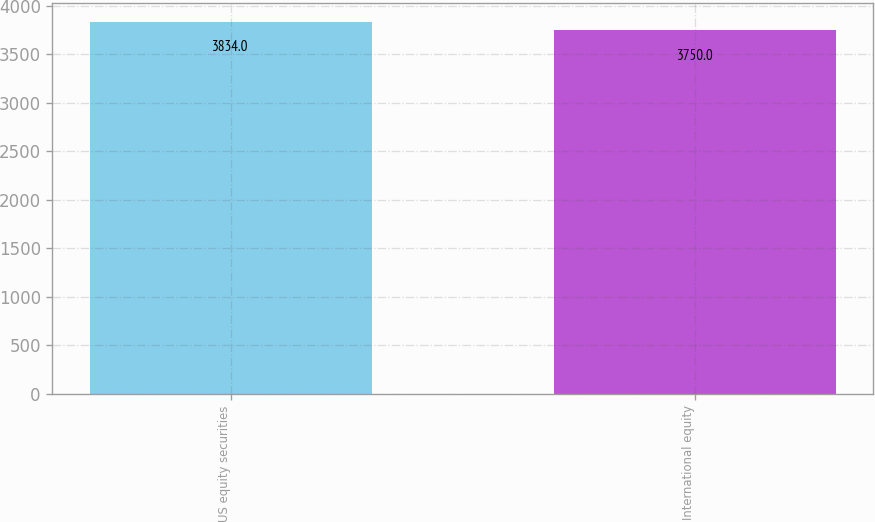Convert chart to OTSL. <chart><loc_0><loc_0><loc_500><loc_500><bar_chart><fcel>US equity securities<fcel>International equity<nl><fcel>3834<fcel>3750<nl></chart> 